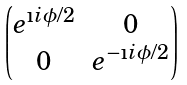Convert formula to latex. <formula><loc_0><loc_0><loc_500><loc_500>\begin{pmatrix} e ^ { \i i \phi / 2 } & 0 \\ 0 & e ^ { - \i i \phi / 2 } \end{pmatrix}</formula> 